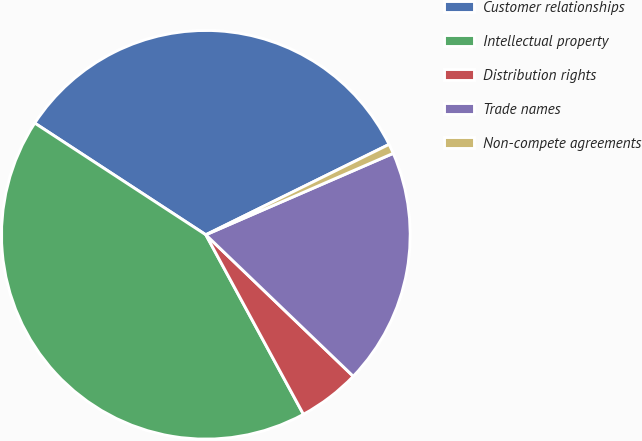Convert chart to OTSL. <chart><loc_0><loc_0><loc_500><loc_500><pie_chart><fcel>Customer relationships<fcel>Intellectual property<fcel>Distribution rights<fcel>Trade names<fcel>Non-compete agreements<nl><fcel>33.5%<fcel>42.13%<fcel>4.9%<fcel>18.7%<fcel>0.77%<nl></chart> 